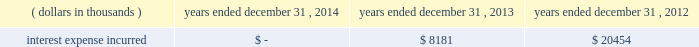Junior subordinated debt securities payable in accordance with the provisions of the junior subordinated debt securities which were issued on march 29 , 2004 , holdings elected to redeem the $ 329897 thousand of 6.2% ( 6.2 % ) junior subordinated debt securities outstanding on may 24 , 2013 .
As a result of the early redemption , the company incurred pre-tax expense of $ 7282 thousand related to the immediate amortization of the remaining capitalized issuance costs on the trust preferred securities .
Interest expense incurred in connection with these junior subordinated debt securities is as follows for the periods indicated: .
Holdings considered the mechanisms and obligations relating to the trust preferred securities , taken together , constituted a full and unconditional guarantee by holdings of capital trust ii 2019s payment obligations with respect to their trust preferred securities .
10 .
Reinsurance and trust agreements certain subsidiaries of group have established trust agreements , which effectively use the company 2019s investments as collateral , as security for assumed losses payable to certain non-affiliated ceding companies .
At december 31 , 2014 , the total amount on deposit in trust accounts was $ 322285 thousand .
On april 24 , 2014 , the company entered into two collateralized reinsurance agreements with kilimanjaro re limited ( 201ckilimanjaro 201d ) , a bermuda based special purpose reinsurer , to provide the company with catastrophe reinsurance coverage .
These agreements are multi-year reinsurance contracts which cover specified named storm and earthquake events .
The first agreement provides up to $ 250000 thousand of reinsurance coverage from named storms in specified states of the southeastern united states .
The second agreement provides up to $ 200000 thousand of reinsurance coverage from named storms in specified states of the southeast , mid-atlantic and northeast regions of the united states and puerto rico as well as reinsurance coverage from earthquakes in specified states of the southeast , mid-atlantic , northeast and west regions of the united states , puerto rico and british columbia .
On november 18 , 2014 , the company entered into a collateralized reinsurance agreement with kilimanjaro re to provide the company with catastrophe reinsurance coverage .
This agreement is a multi-year reinsurance contract which covers specified earthquake events .
The agreement provides up to $ 500000 thousand of reinsurance coverage from earthquakes in the united states , puerto rico and canada .
Kilimanjaro has financed the various property catastrophe reinsurance coverage by issuing catastrophe bonds to unrelated , external investors .
On april 24 , 2014 , kilimanjaro issued $ 450000 thousand of variable rate notes ( 201cseries 2014-1 notes 201d ) .
On november 18 , 2014 , kilimanjaro issued $ 500000 thousand of variable rate notes ( 201cseries 2014-2 notes 201d ) .
The proceeds from the issuance of the series 2014-1 notes and the series 2014-2 notes are held in reinsurance trust throughout the duration of the applicable reinsurance agreements and invested solely in us government money market funds with a rating of at least 201caaam 201d by standard & poor 2019s. .
What was the ratio of interest incurred in 2013 to 2012? 
Rationale: the company incurred $ 0.39 in 2013 for every dollar incurred in 2012
Computations: (8181 + 20454)
Answer: 28635.0. 